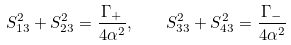Convert formula to latex. <formula><loc_0><loc_0><loc_500><loc_500>S _ { 1 3 } ^ { 2 } + S _ { 2 3 } ^ { 2 } = \frac { \Gamma _ { + } } { 4 \alpha ^ { 2 } } , \quad S _ { 3 3 } ^ { 2 } + S _ { 4 3 } ^ { 2 } = \frac { \Gamma _ { - } } { 4 \alpha ^ { 2 } }</formula> 